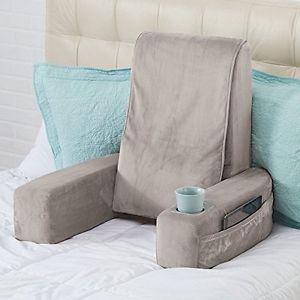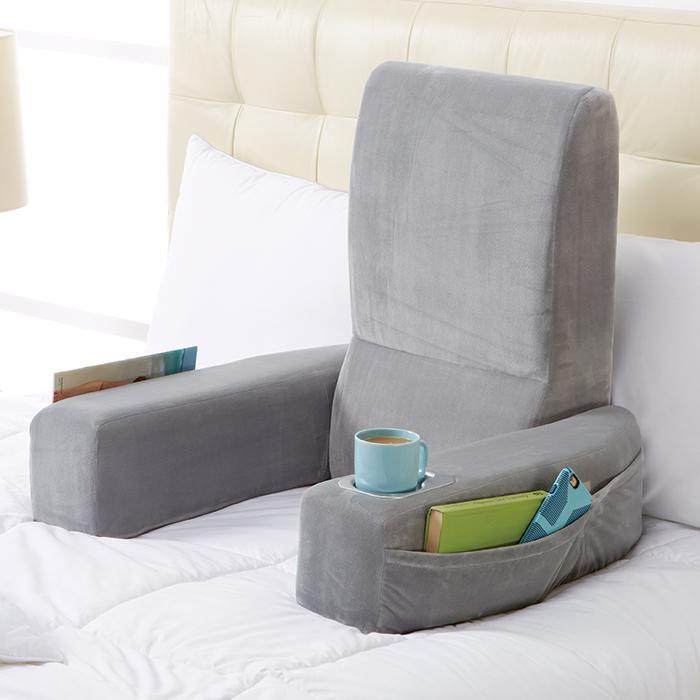The first image is the image on the left, the second image is the image on the right. Examine the images to the left and right. Is the description "At least one image features an upright bedrest with a cupholder and pouch in one arm." accurate? Answer yes or no. Yes. The first image is the image on the left, the second image is the image on the right. For the images shown, is this caption "One or more images shows a backrest pillow holding a cup in a cup holder on one of the arms along with items in a side pocket" true? Answer yes or no. Yes. 